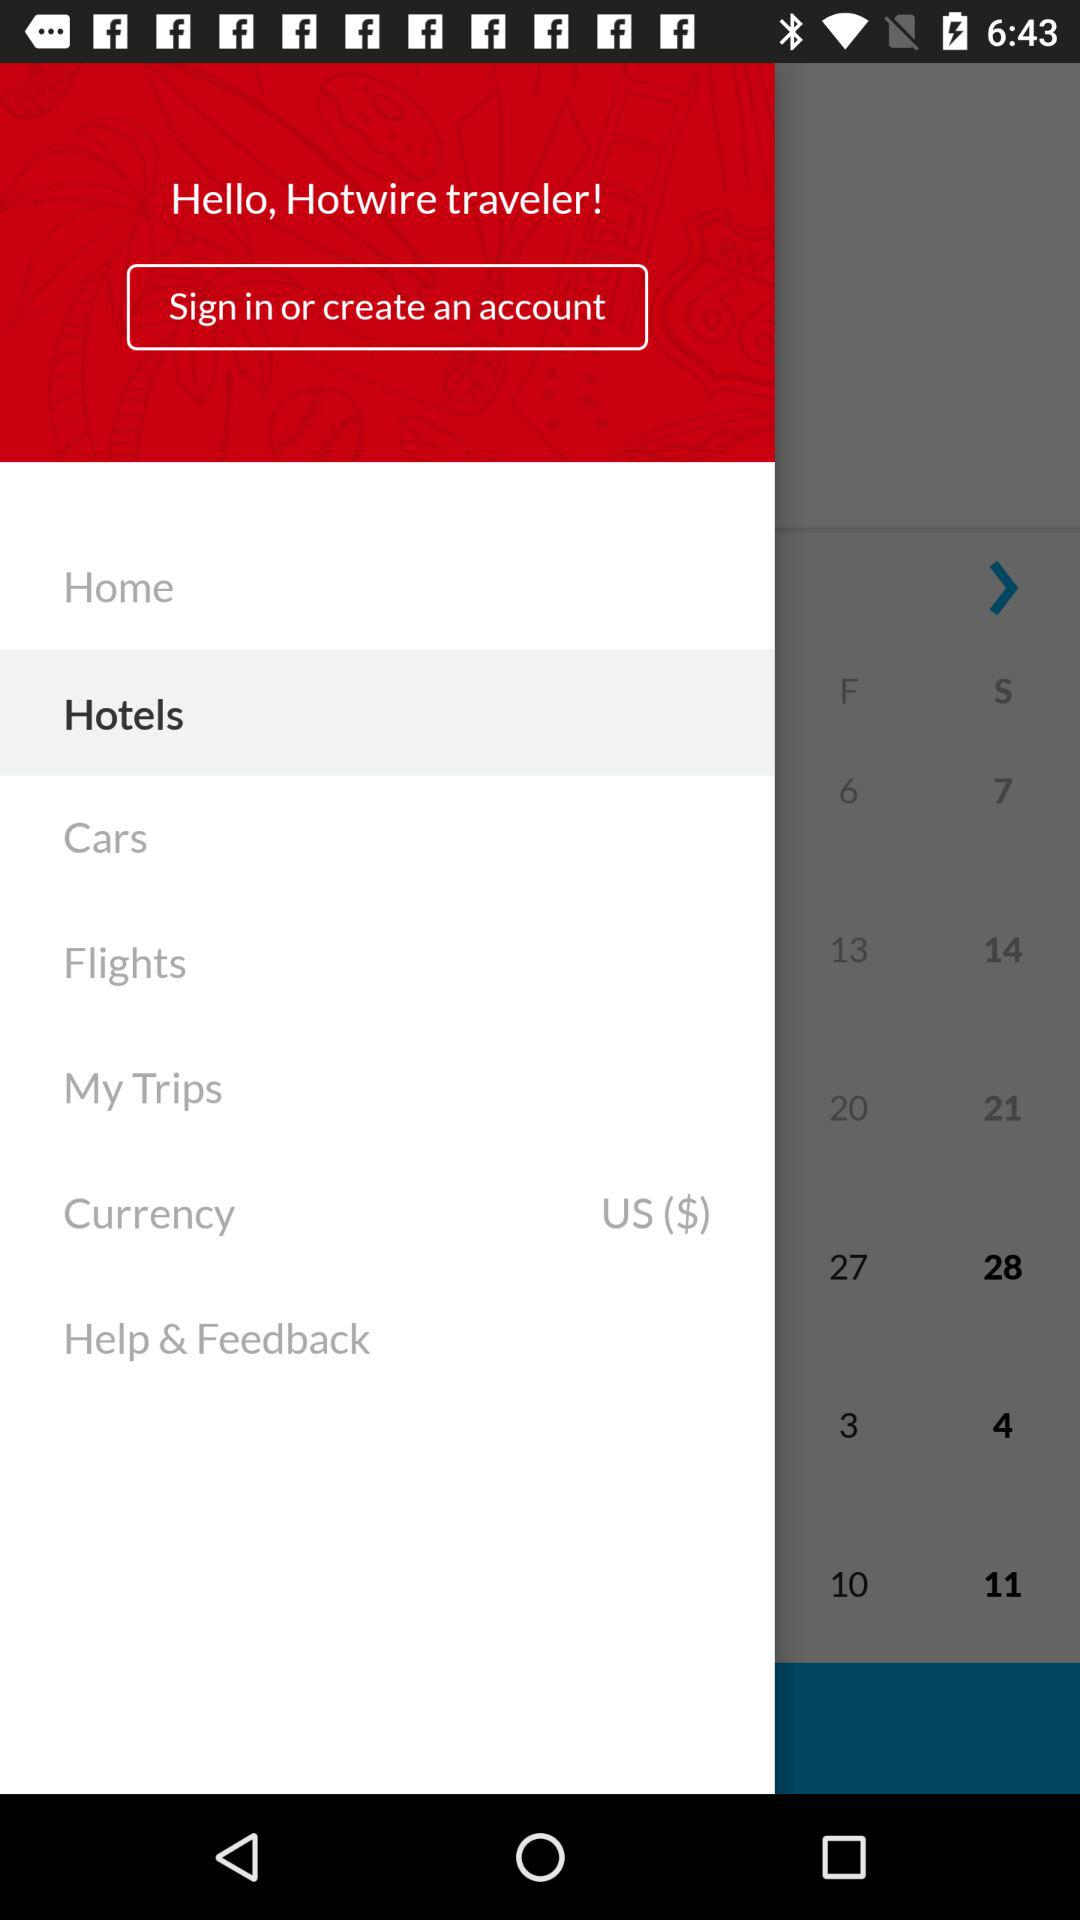Which option is highlighted? The highlighted option is "Hotels". 